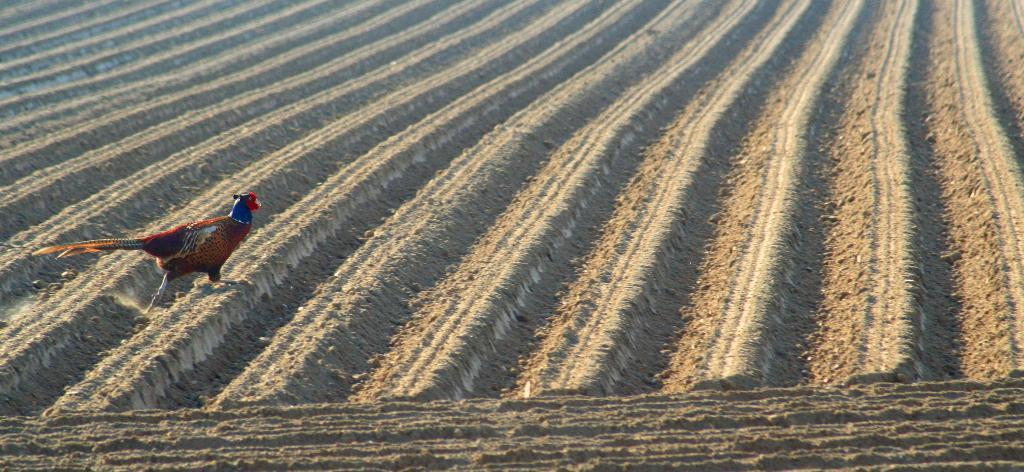What type of landscape can be seen in the image? There is cultivated land with ridges in the image. Are there any animals present in the image? Yes, there is a bird on the land. What colors can be seen on the bird? The bird has brown, blue, and red colors. What is the bird doing in the image? The bird is walking. How does the bird increase its speed while walking in the image? The bird does not increase its speed in the image; it is simply walking. What type of fish can be seen swimming in the cultivated land? There are no fish present in the image, as it features cultivated land and a bird. 